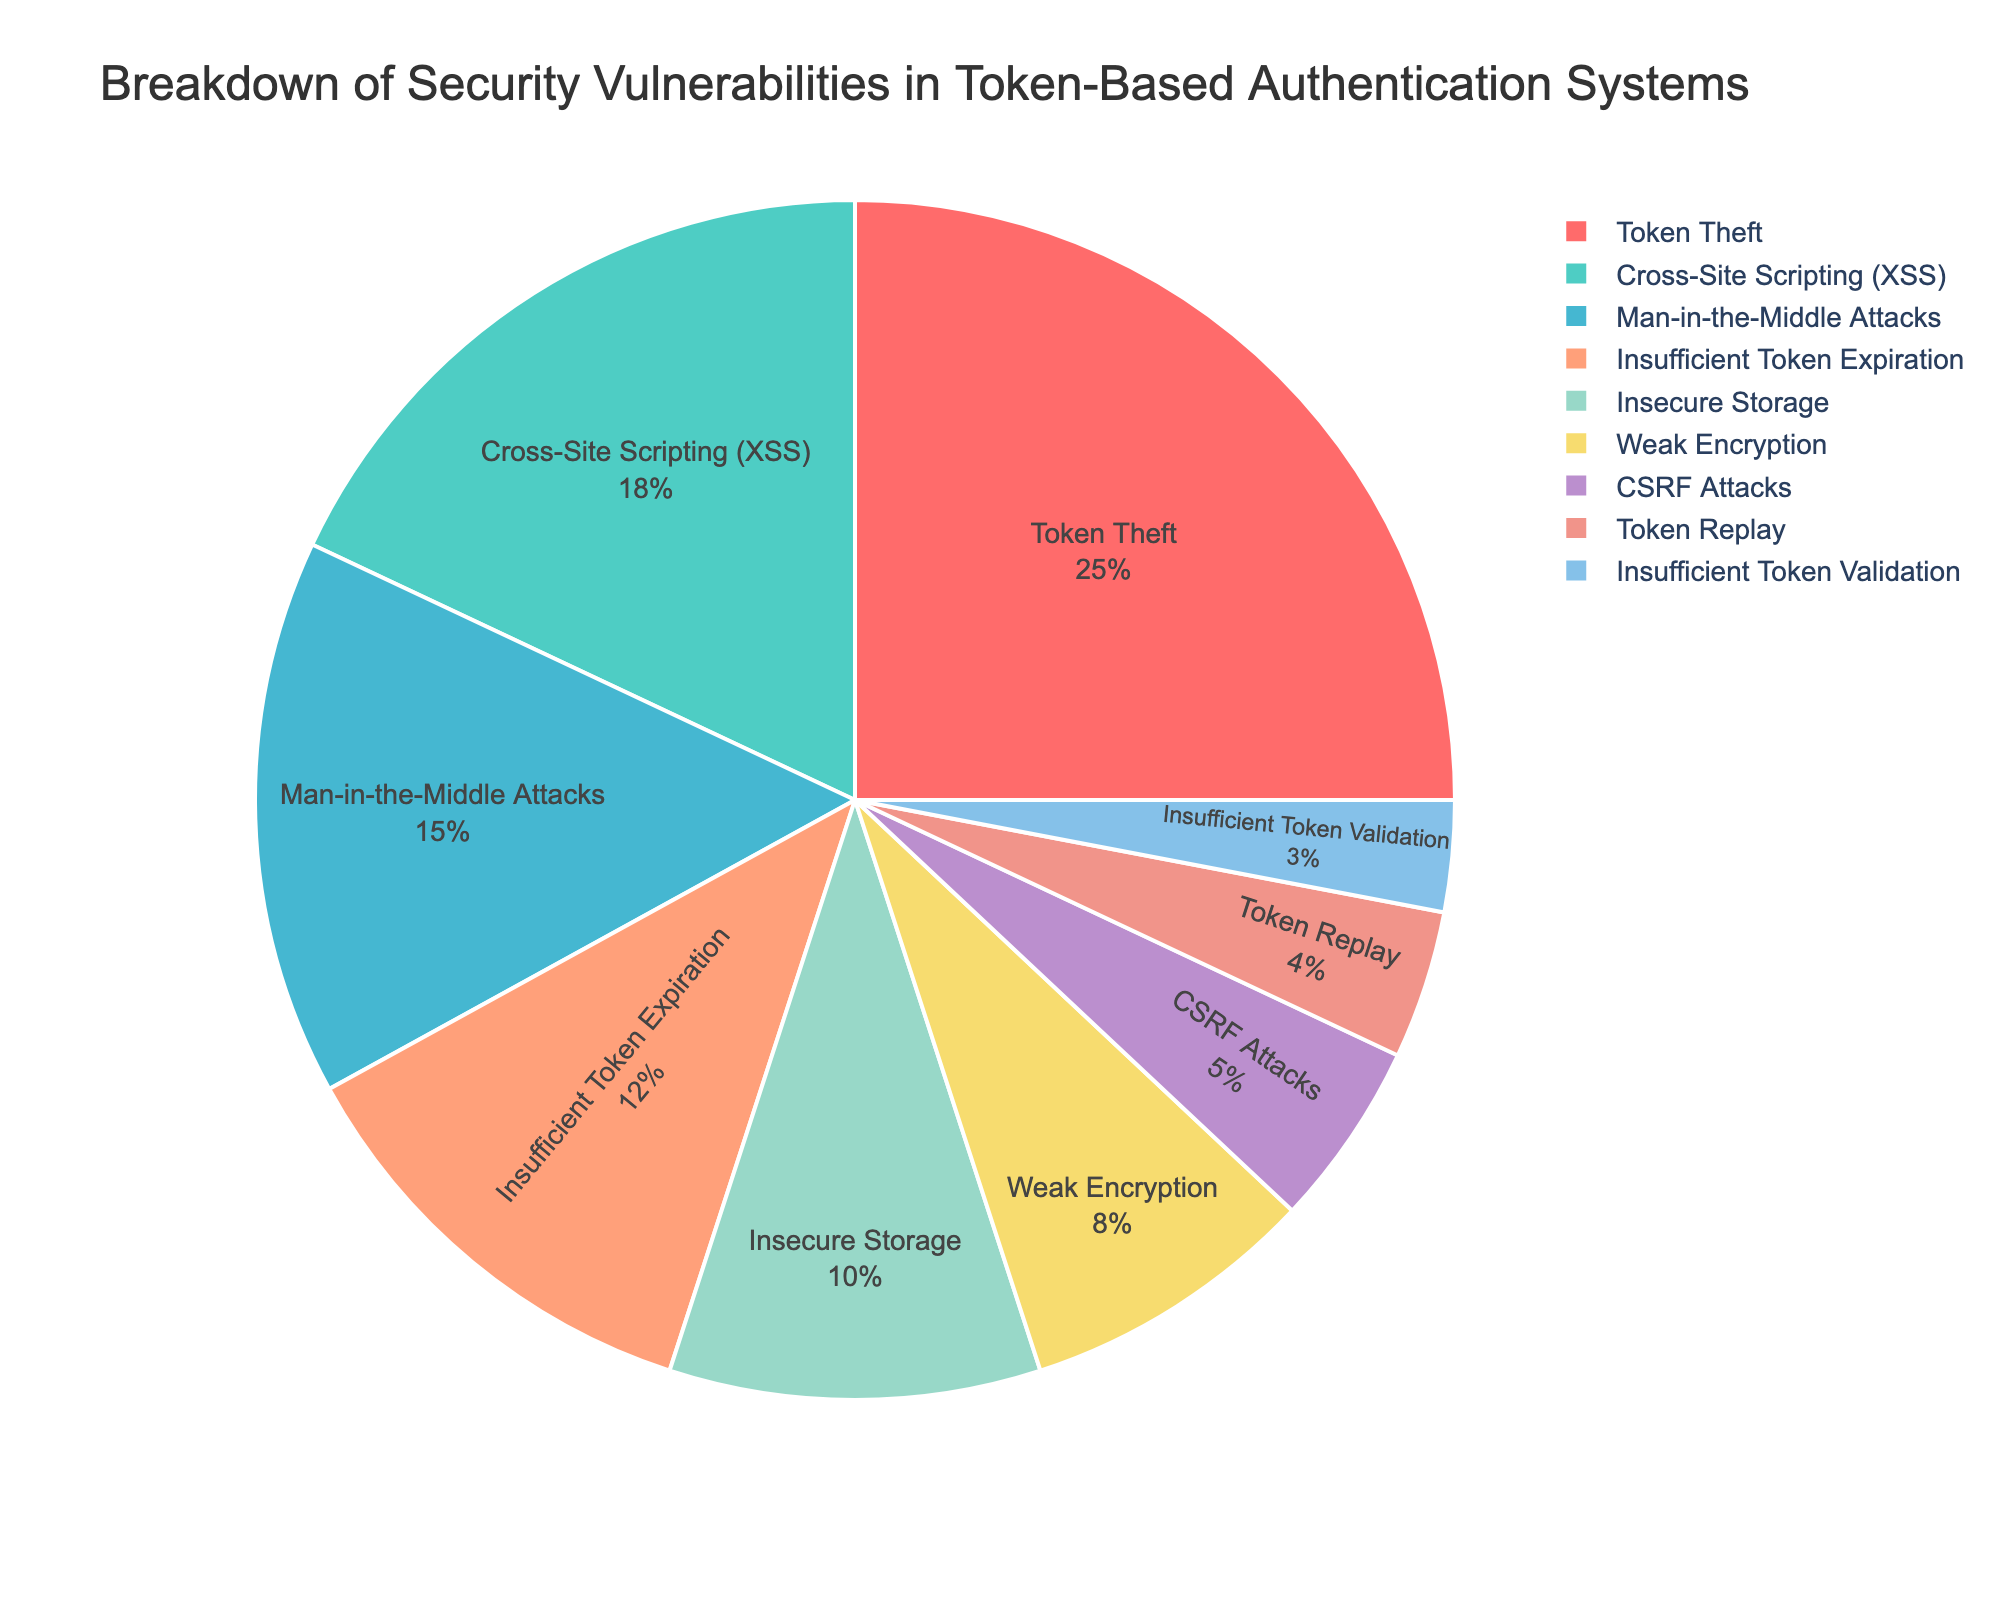What is the most common security vulnerability in token-based authentication systems? The segment with the highest percentage in the pie chart stands out visually, which is labeled "Token Theft" and accounts for 25%.
Answer: Token Theft Which vulnerability has a higher percentage: Cross-Site Scripting (XSS) or Man-in-the-Middle Attacks? By comparing the two segments, Cross-Site Scripting has 18% while Man-in-the-Middle Attacks has 15%. Since 18% is greater than 15%, Cross-Site Scripting (XSS) is higher.
Answer: Cross-Site Scripting (XSS) What combined percentage of security vulnerabilities do insufficient token expiration and insecure storage represent? Add the percentages for Insufficient Token Expiration (12%) and Insecure Storage (10%). The combined total is 12% + 10% = 22%.
Answer: 22% How many vulnerabilities have a percentage less than 10%? Visually identify all segments with percentages less than 10%: Weak Encryption (8%), CSRF Attacks (5%), Token Replay (4%), and Insufficient Token Validation (3%). There are four segments in total.
Answer: 4 Is the percentage for Weak Encryption greater than, less than, or equal to half that of Token Theft? Token Theft has 25%. Half of 25% is 12.5%. Weak Encryption has 8%, which is less than 12.5%.
Answer: Less than Which two vulnerabilities combined equal the percentage of Cross-Site Scripting (XSS)? Cross-Site Scripting (XSS) has 18%. The combined percentages of Weak Encryption (8%) and Man-in-the-Middle Attacks (15%) exceed 18%, so look for two smaller percentages. Insecure Storage (10%) plus Insufficient Token Expiration (12%) equals 22% and doesn't fit. Weak Encryption (8%) and Insecure Storage (10%) combined have 18%. Thus, Weak Encryption and Insecure Storage combine to match the percentage of Cross-Site Scripting (XSS).
Answer: Weak Encryption and Insecure Storage What percentage is represented by vulnerabilities categorized under Cross-Site Scripting (XSS) and CSRF Attacks combined? Add the percentages for Cross-Site Scripting (XSS) and CSRF Attacks. 18% + 5% = 23%.
Answer: 23% What is the smallest categorized vulnerability in the pie chart? The segment with the smallest percentage is Insufficient Token Validation, which is labeled at 3%.
Answer: Insufficient Token Validation 